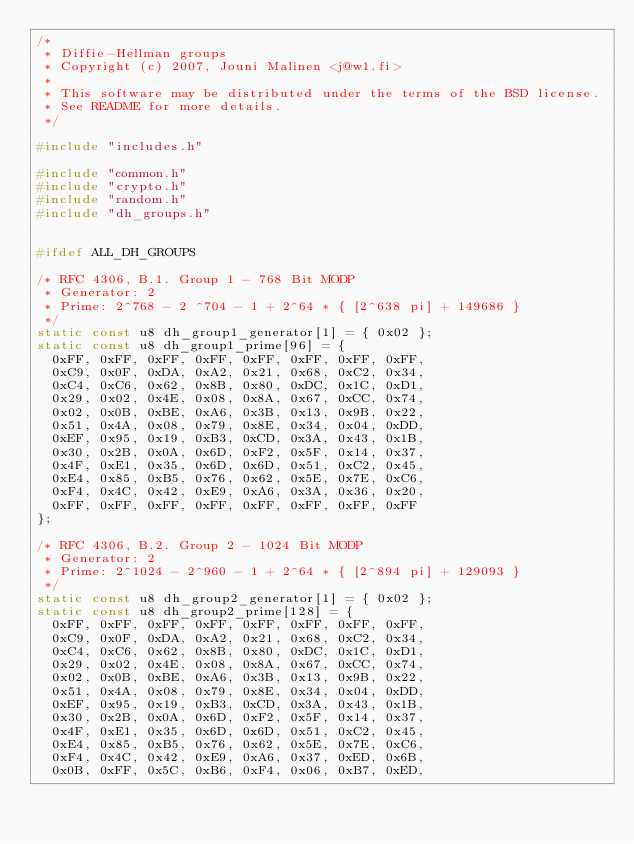Convert code to text. <code><loc_0><loc_0><loc_500><loc_500><_C_>/*
 * Diffie-Hellman groups
 * Copyright (c) 2007, Jouni Malinen <j@w1.fi>
 *
 * This software may be distributed under the terms of the BSD license.
 * See README for more details.
 */

#include "includes.h"

#include "common.h"
#include "crypto.h"
#include "random.h"
#include "dh_groups.h"


#ifdef ALL_DH_GROUPS

/* RFC 4306, B.1. Group 1 - 768 Bit MODP
 * Generator: 2
 * Prime: 2^768 - 2 ^704 - 1 + 2^64 * { [2^638 pi] + 149686 }
 */
static const u8 dh_group1_generator[1] = { 0x02 };
static const u8 dh_group1_prime[96] = {
	0xFF, 0xFF, 0xFF, 0xFF, 0xFF, 0xFF, 0xFF, 0xFF,
	0xC9, 0x0F, 0xDA, 0xA2, 0x21, 0x68, 0xC2, 0x34,
	0xC4, 0xC6, 0x62, 0x8B, 0x80, 0xDC, 0x1C, 0xD1,
	0x29, 0x02, 0x4E, 0x08, 0x8A, 0x67, 0xCC, 0x74,
	0x02, 0x0B, 0xBE, 0xA6, 0x3B, 0x13, 0x9B, 0x22,
	0x51, 0x4A, 0x08, 0x79, 0x8E, 0x34, 0x04, 0xDD,
	0xEF, 0x95, 0x19, 0xB3, 0xCD, 0x3A, 0x43, 0x1B,
	0x30, 0x2B, 0x0A, 0x6D, 0xF2, 0x5F, 0x14, 0x37,
	0x4F, 0xE1, 0x35, 0x6D, 0x6D, 0x51, 0xC2, 0x45,
	0xE4, 0x85, 0xB5, 0x76, 0x62, 0x5E, 0x7E, 0xC6,
	0xF4, 0x4C, 0x42, 0xE9, 0xA6, 0x3A, 0x36, 0x20,
	0xFF, 0xFF, 0xFF, 0xFF, 0xFF, 0xFF, 0xFF, 0xFF
};

/* RFC 4306, B.2. Group 2 - 1024 Bit MODP
 * Generator: 2
 * Prime: 2^1024 - 2^960 - 1 + 2^64 * { [2^894 pi] + 129093 }
 */
static const u8 dh_group2_generator[1] = { 0x02 };
static const u8 dh_group2_prime[128] = {
	0xFF, 0xFF, 0xFF, 0xFF, 0xFF, 0xFF, 0xFF, 0xFF,
	0xC9, 0x0F, 0xDA, 0xA2, 0x21, 0x68, 0xC2, 0x34,
	0xC4, 0xC6, 0x62, 0x8B, 0x80, 0xDC, 0x1C, 0xD1,
	0x29, 0x02, 0x4E, 0x08, 0x8A, 0x67, 0xCC, 0x74,
	0x02, 0x0B, 0xBE, 0xA6, 0x3B, 0x13, 0x9B, 0x22,
	0x51, 0x4A, 0x08, 0x79, 0x8E, 0x34, 0x04, 0xDD,
	0xEF, 0x95, 0x19, 0xB3, 0xCD, 0x3A, 0x43, 0x1B,
	0x30, 0x2B, 0x0A, 0x6D, 0xF2, 0x5F, 0x14, 0x37,
	0x4F, 0xE1, 0x35, 0x6D, 0x6D, 0x51, 0xC2, 0x45,
	0xE4, 0x85, 0xB5, 0x76, 0x62, 0x5E, 0x7E, 0xC6,
	0xF4, 0x4C, 0x42, 0xE9, 0xA6, 0x37, 0xED, 0x6B,
	0x0B, 0xFF, 0x5C, 0xB6, 0xF4, 0x06, 0xB7, 0xED,</code> 